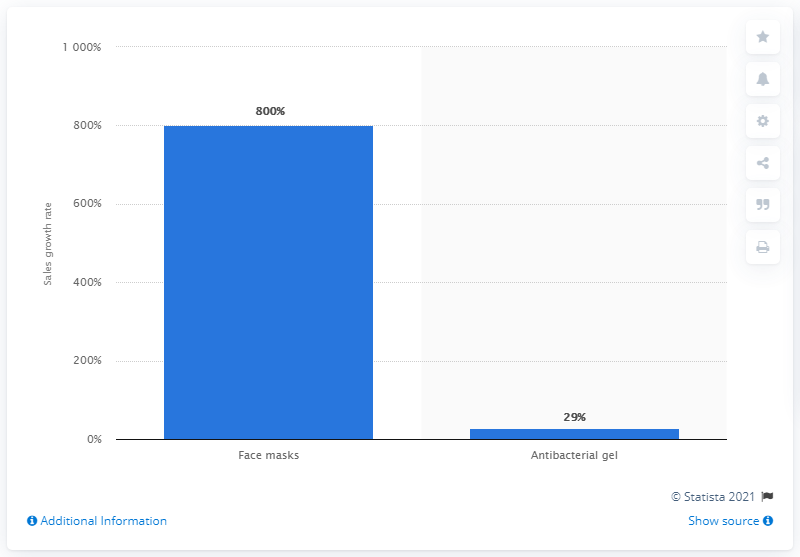Specify some key components in this picture. Sales of antibacterial gel increased by 29% In February 2020, Chile's sales growth of face masks was 800%. 